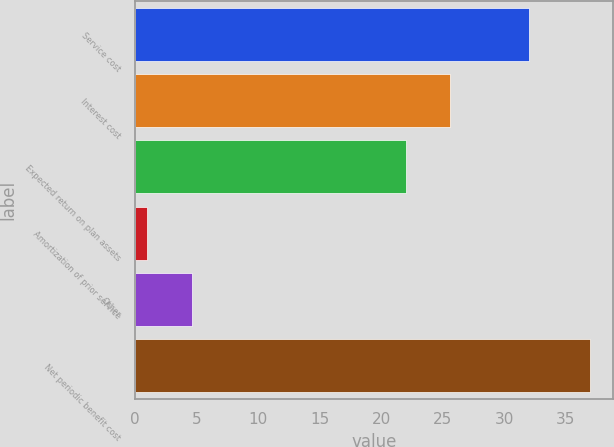Convert chart to OTSL. <chart><loc_0><loc_0><loc_500><loc_500><bar_chart><fcel>Service cost<fcel>Interest cost<fcel>Expected return on plan assets<fcel>Amortization of prior service<fcel>Other<fcel>Net periodic benefit cost<nl><fcel>32<fcel>25.6<fcel>22<fcel>1<fcel>4.6<fcel>37<nl></chart> 